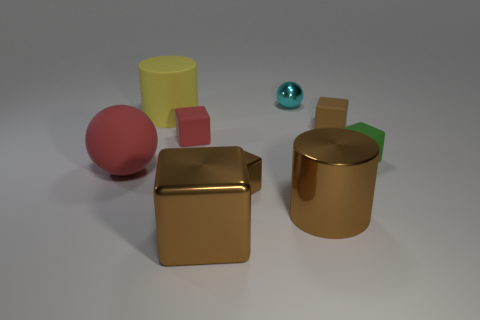Subtract all purple balls. How many brown blocks are left? 3 Subtract 1 blocks. How many blocks are left? 4 Subtract all green cubes. How many cubes are left? 4 Subtract all tiny red cubes. How many cubes are left? 4 Subtract all purple cubes. Subtract all brown cylinders. How many cubes are left? 5 Add 1 brown rubber blocks. How many objects exist? 10 Subtract all cubes. How many objects are left? 4 Add 3 shiny objects. How many shiny objects are left? 7 Add 8 big blue balls. How many big blue balls exist? 8 Subtract 0 gray balls. How many objects are left? 9 